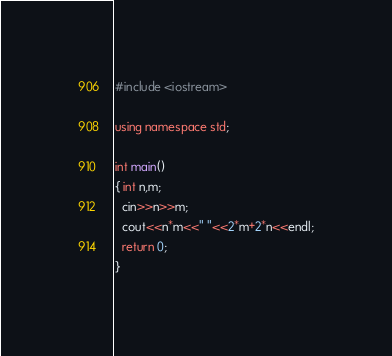Convert code to text. <code><loc_0><loc_0><loc_500><loc_500><_C++_>#include <iostream>

using namespace std;

int main()
{ int n,m;
  cin>>n>>m;
  cout<<n*m<<" "<<2*m+2*n<<endl;
  return 0;
}

</code> 